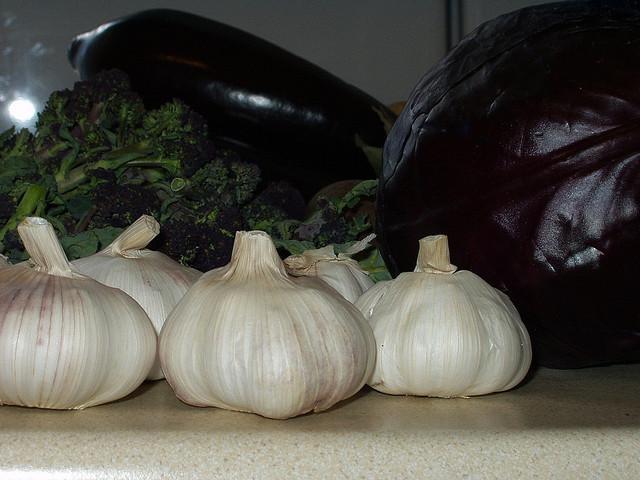How many garlic bulbs are there?
Give a very brief answer. 5. How many broccolis can you see?
Give a very brief answer. 5. How many people are wearing pink dresses?
Give a very brief answer. 0. 